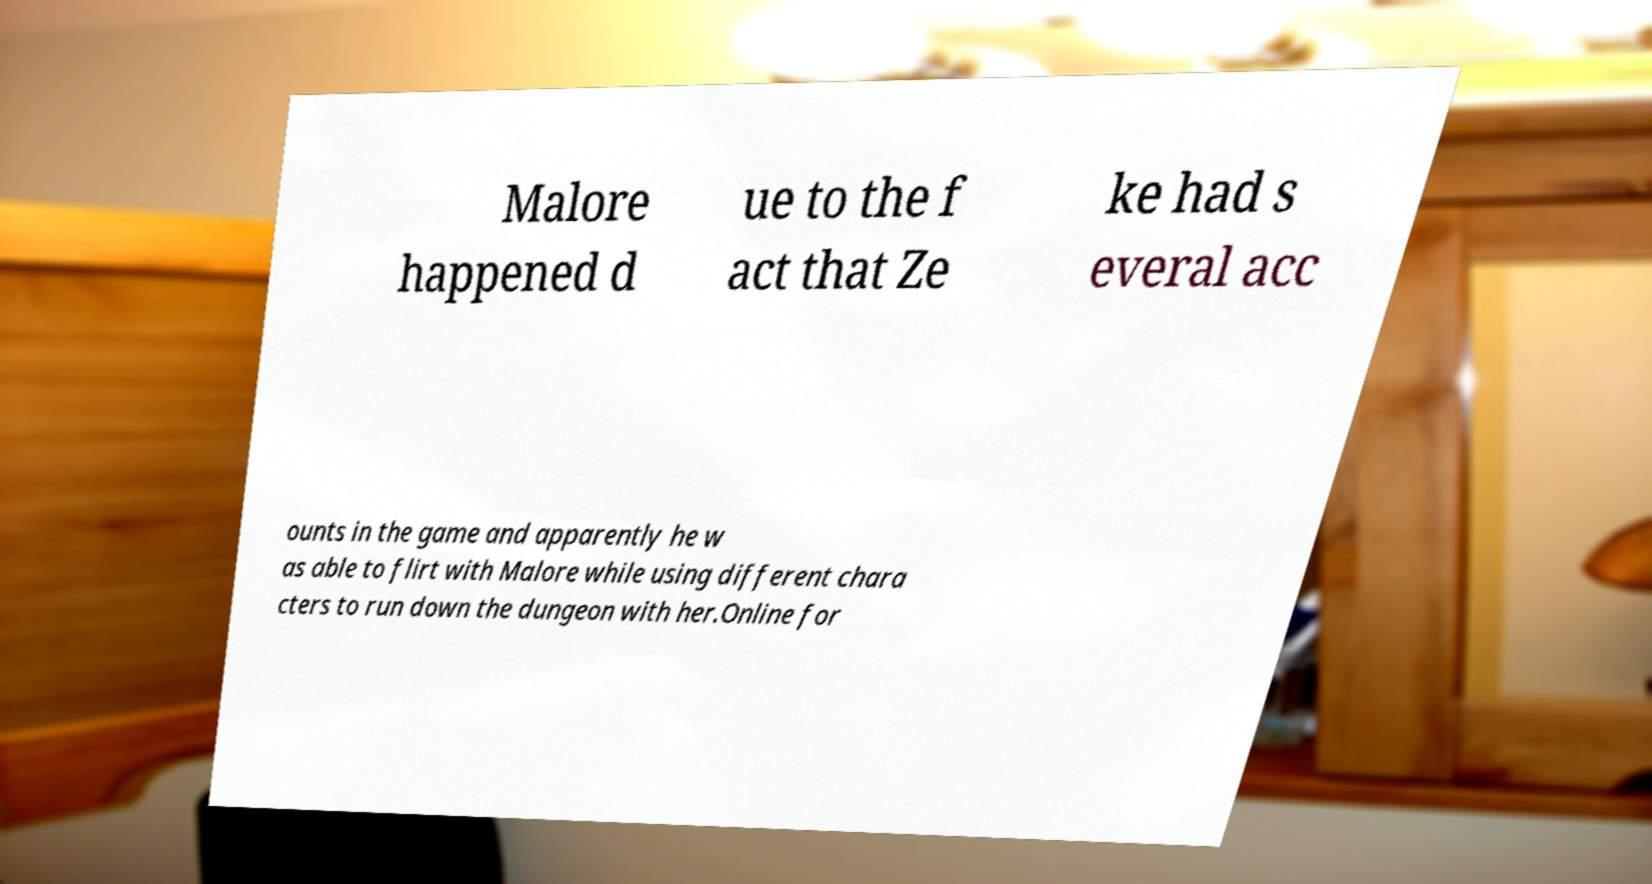There's text embedded in this image that I need extracted. Can you transcribe it verbatim? Malore happened d ue to the f act that Ze ke had s everal acc ounts in the game and apparently he w as able to flirt with Malore while using different chara cters to run down the dungeon with her.Online for 